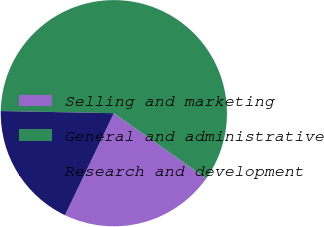Convert chart to OTSL. <chart><loc_0><loc_0><loc_500><loc_500><pie_chart><fcel>Selling and marketing<fcel>General and administrative<fcel>Research and development<nl><fcel>22.32%<fcel>59.48%<fcel>18.19%<nl></chart> 